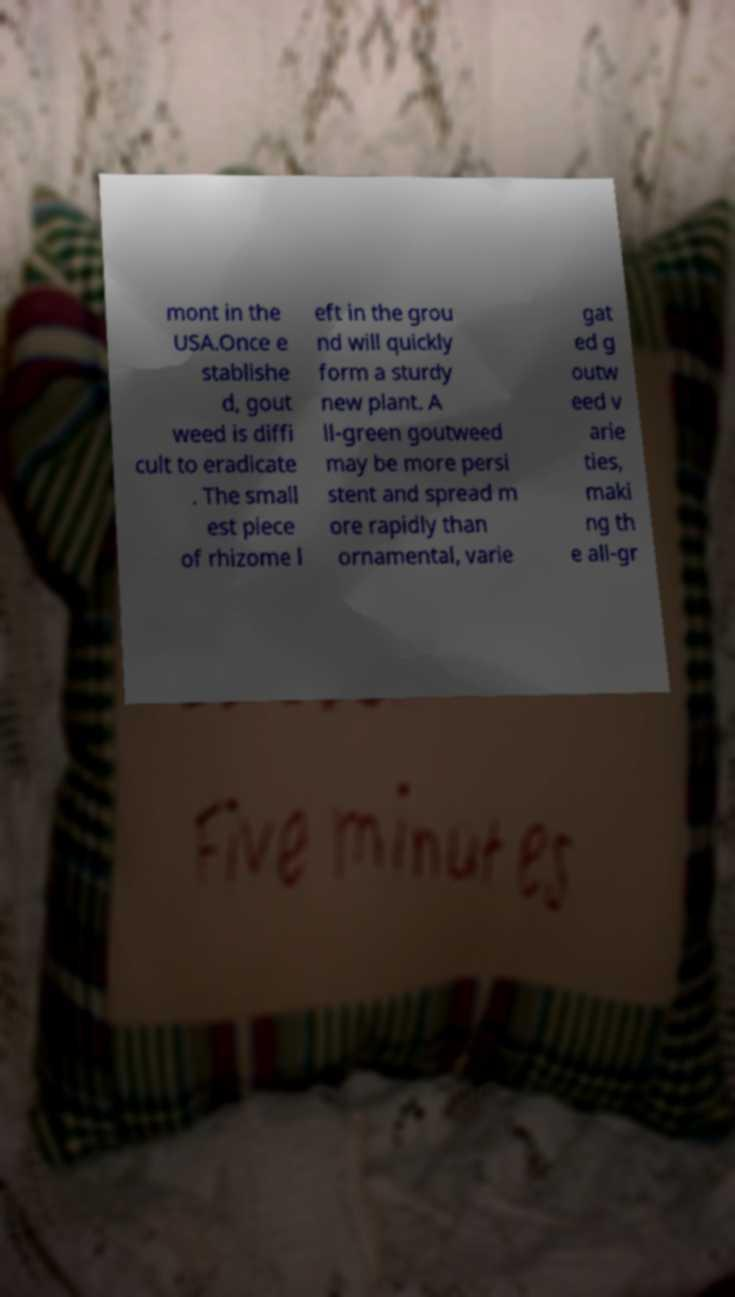Please read and relay the text visible in this image. What does it say? mont in the USA.Once e stablishe d, gout weed is diffi cult to eradicate . The small est piece of rhizome l eft in the grou nd will quickly form a sturdy new plant. A ll-green goutweed may be more persi stent and spread m ore rapidly than ornamental, varie gat ed g outw eed v arie ties, maki ng th e all-gr 